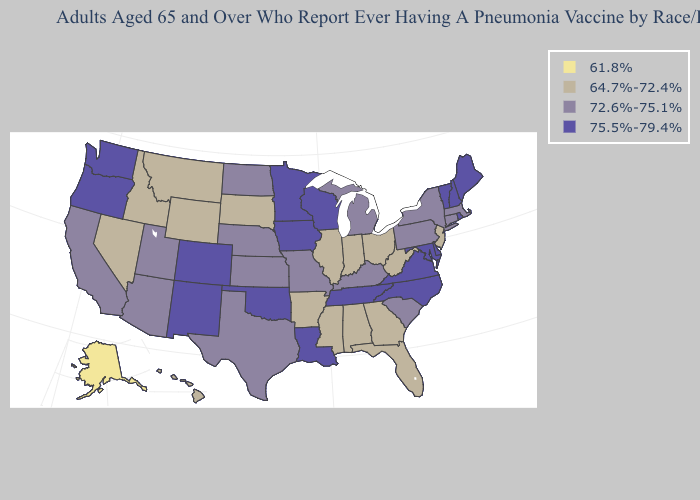What is the value of Vermont?
Keep it brief. 75.5%-79.4%. Does Georgia have the lowest value in the South?
Short answer required. Yes. What is the value of Washington?
Concise answer only. 75.5%-79.4%. Name the states that have a value in the range 72.6%-75.1%?
Short answer required. Arizona, California, Connecticut, Kansas, Kentucky, Massachusetts, Michigan, Missouri, Nebraska, New York, North Dakota, Pennsylvania, South Carolina, Texas, Utah. Name the states that have a value in the range 61.8%?
Be succinct. Alaska. Does Georgia have the highest value in the South?
Write a very short answer. No. What is the highest value in the MidWest ?
Answer briefly. 75.5%-79.4%. What is the value of Florida?
Be succinct. 64.7%-72.4%. What is the value of West Virginia?
Keep it brief. 64.7%-72.4%. What is the lowest value in states that border Georgia?
Give a very brief answer. 64.7%-72.4%. What is the lowest value in states that border Minnesota?
Concise answer only. 64.7%-72.4%. Does Alaska have the lowest value in the USA?
Short answer required. Yes. What is the value of Massachusetts?
Be succinct. 72.6%-75.1%. Name the states that have a value in the range 64.7%-72.4%?
Be succinct. Alabama, Arkansas, Florida, Georgia, Hawaii, Idaho, Illinois, Indiana, Mississippi, Montana, Nevada, New Jersey, Ohio, South Dakota, West Virginia, Wyoming. 